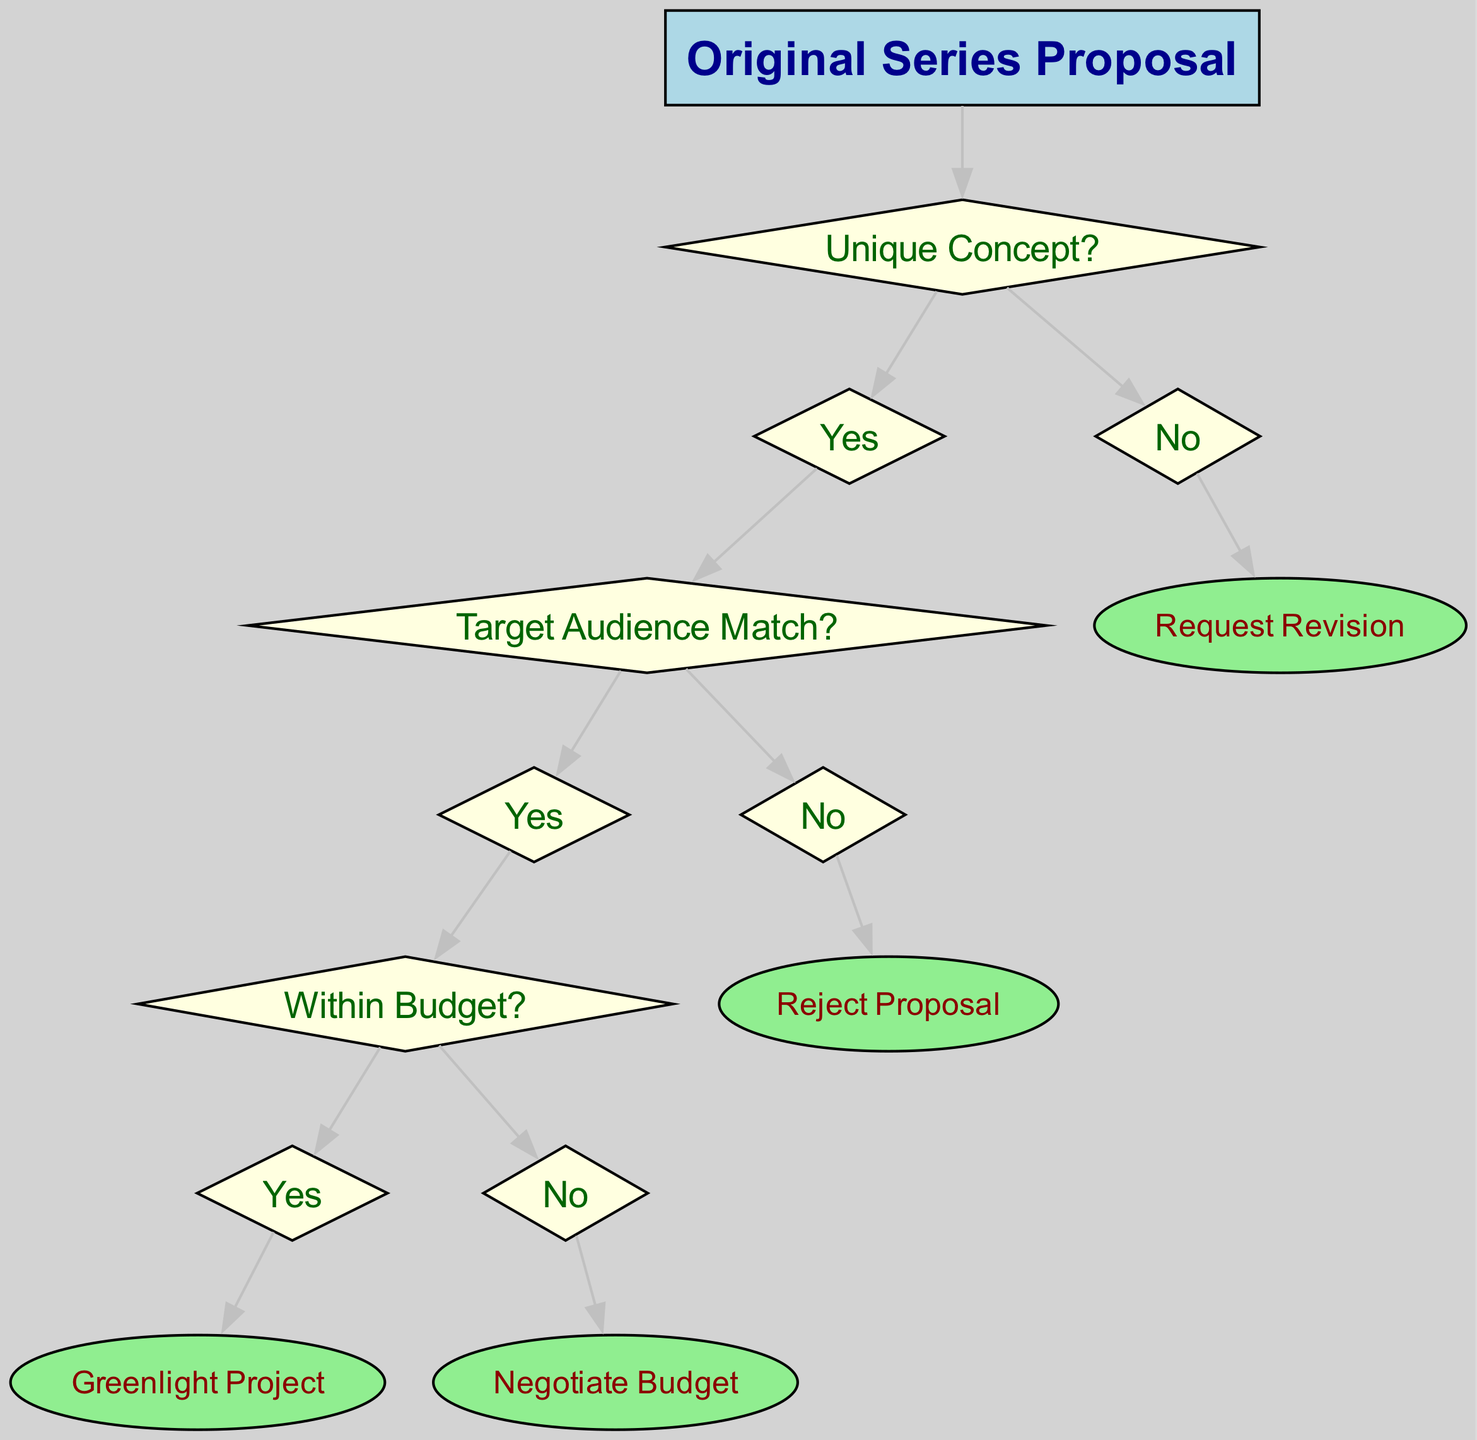What is the root of the decision tree? The root of the decision tree is clearly labeled as "Original Series Proposal," indicating the starting point of the decision-making process.
Answer: Original Series Proposal How many child nodes does the node "Unique Concept?" have? The node "Unique Concept?" has two child nodes: "Yes" and "No," illustrating the binary decision at this stage.
Answer: 2 What happens if the proposal does not have a unique concept? If the proposal does not have a unique concept, the decision tree leads to the node "Request Revision," indicating further action required.
Answer: Request Revision What is the outcome if the target audience does not match? If the target audience does not match, the next action is to "Reject Proposal," reflecting a negative decision at that point in the flow.
Answer: Reject Proposal Which node leads to "Greenlight Project"? The path to "Greenlight Project" follows from "Unique Concept?" to "Target Audience Match?" and then to "Within Budget?" before reaching this final decision.
Answer: Within Budget How many total nodes are present in the decision tree? The decision tree includes a total of six distinct nodes: root, Unique Concept?, Target Audience Match?, Within Budget?, Greenlight Project, and Request Revision, when counted together.
Answer: 6 What does the node "Negotiate Budget" represent? The node "Negotiate Budget" signifies the action to be taken if the proposal is within the target audience but not within the budget, allowing for budget discussions.
Answer: Negotiate Budget If a proposal has a unique concept and a target audience match, but exceeds the budget, what is the next step? If the proposal meets the first two conditions but does not stay within budget, the next step indicated by the diagram is to "Negotiate Budget."
Answer: Negotiate Budget What decision is made if all criteria are met? If the proposal has a unique concept, matches the target audience, and is within the budget, the final decision made is to "Greenlight Project."
Answer: Greenlight Project 